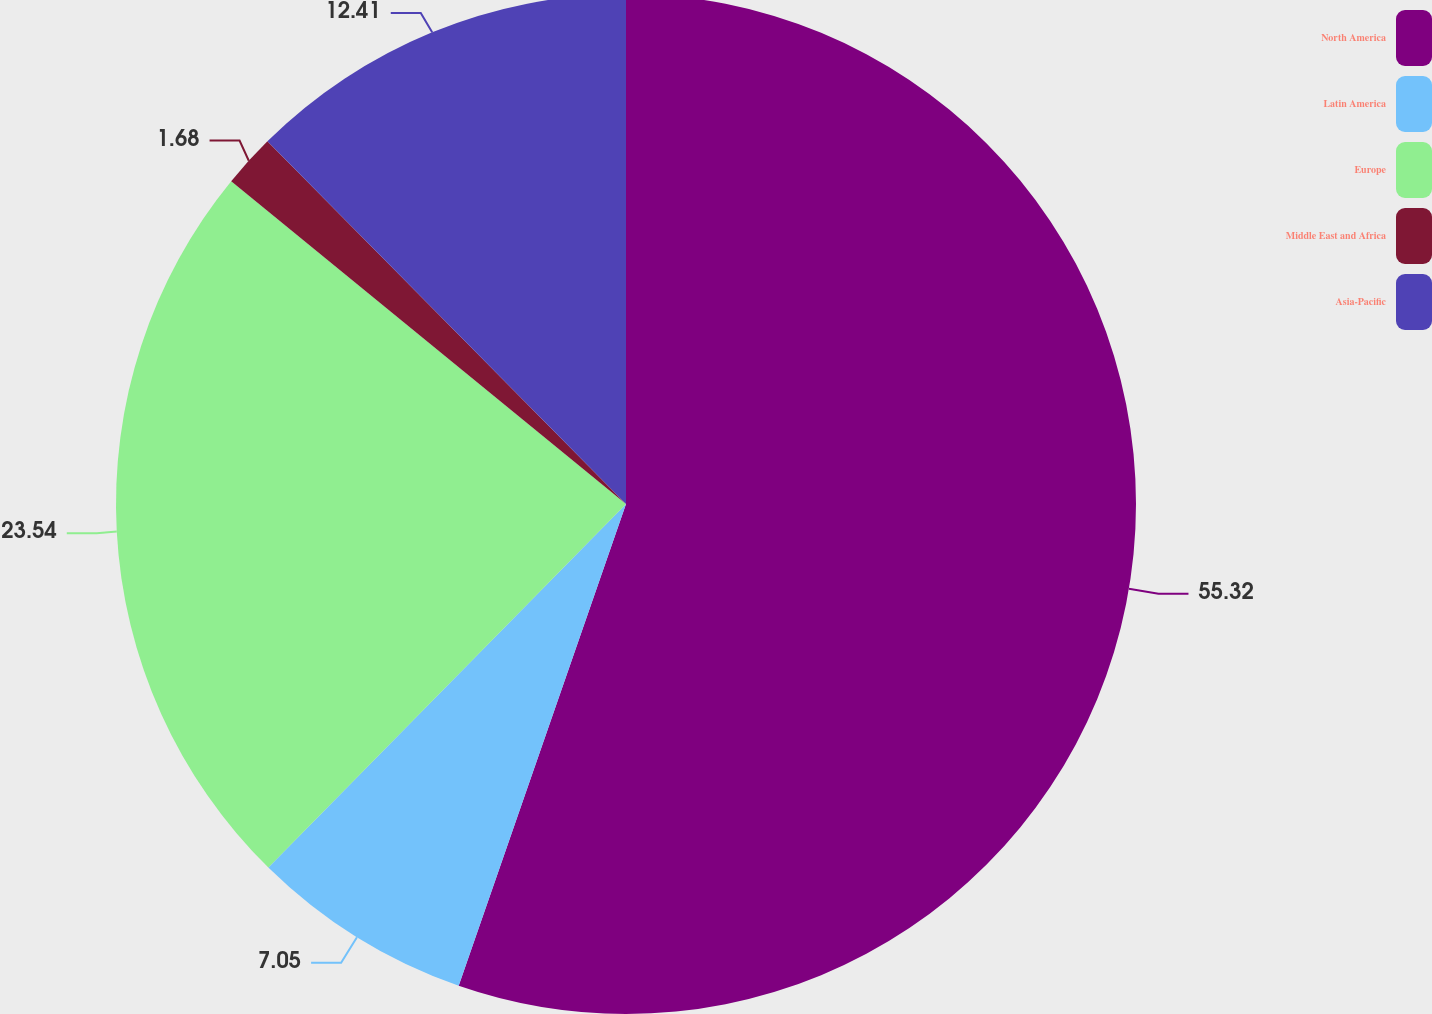<chart> <loc_0><loc_0><loc_500><loc_500><pie_chart><fcel>North America<fcel>Latin America<fcel>Europe<fcel>Middle East and Africa<fcel>Asia-Pacific<nl><fcel>55.32%<fcel>7.05%<fcel>23.54%<fcel>1.68%<fcel>12.41%<nl></chart> 